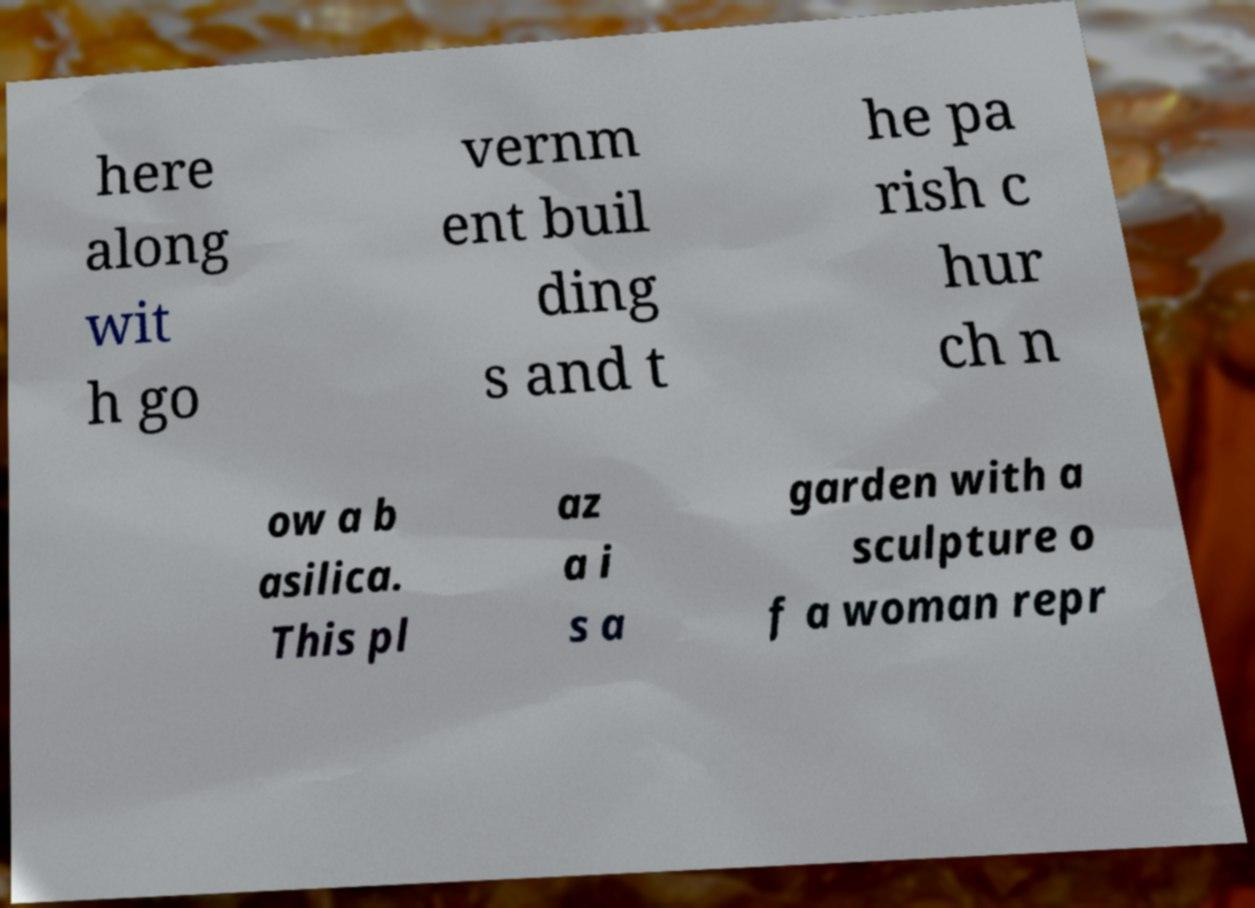I need the written content from this picture converted into text. Can you do that? here along wit h go vernm ent buil ding s and t he pa rish c hur ch n ow a b asilica. This pl az a i s a garden with a sculpture o f a woman repr 